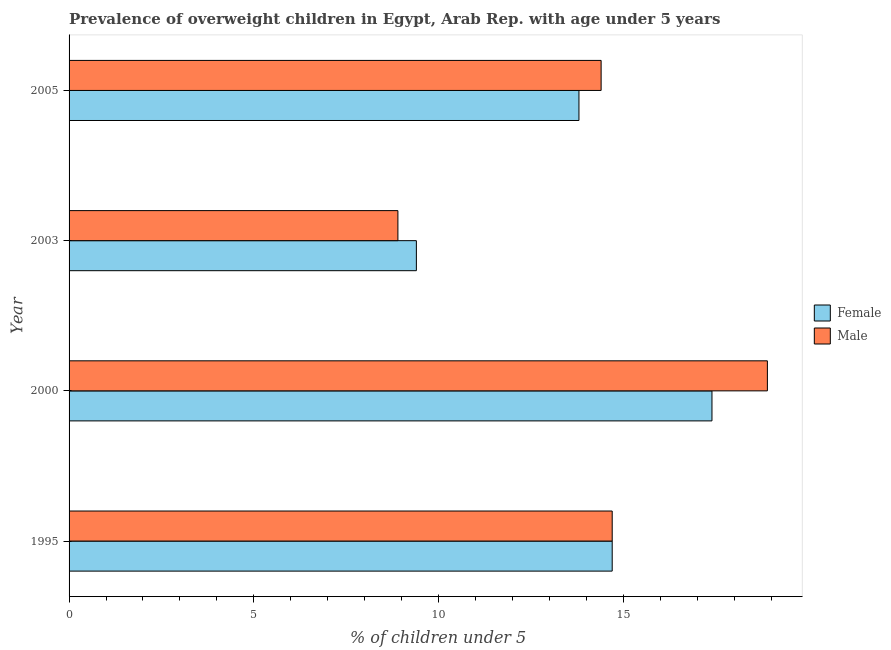How many different coloured bars are there?
Make the answer very short. 2. How many groups of bars are there?
Provide a succinct answer. 4. Are the number of bars on each tick of the Y-axis equal?
Provide a succinct answer. Yes. What is the label of the 4th group of bars from the top?
Provide a succinct answer. 1995. In how many cases, is the number of bars for a given year not equal to the number of legend labels?
Keep it short and to the point. 0. What is the percentage of obese female children in 2003?
Offer a very short reply. 9.4. Across all years, what is the maximum percentage of obese female children?
Give a very brief answer. 17.4. Across all years, what is the minimum percentage of obese male children?
Provide a short and direct response. 8.9. What is the total percentage of obese female children in the graph?
Give a very brief answer. 55.3. What is the difference between the percentage of obese female children in 1995 and that in 2000?
Provide a short and direct response. -2.7. What is the difference between the percentage of obese female children in 2000 and the percentage of obese male children in 2003?
Give a very brief answer. 8.5. What is the average percentage of obese male children per year?
Your response must be concise. 14.22. What is the ratio of the percentage of obese female children in 1995 to that in 2000?
Give a very brief answer. 0.84. Is the difference between the percentage of obese male children in 1995 and 2000 greater than the difference between the percentage of obese female children in 1995 and 2000?
Offer a terse response. No. What is the difference between the highest and the second highest percentage of obese female children?
Ensure brevity in your answer.  2.7. In how many years, is the percentage of obese male children greater than the average percentage of obese male children taken over all years?
Offer a terse response. 3. Is the sum of the percentage of obese female children in 2000 and 2003 greater than the maximum percentage of obese male children across all years?
Your response must be concise. Yes. What does the 1st bar from the top in 2003 represents?
Provide a succinct answer. Male. What does the 1st bar from the bottom in 2003 represents?
Give a very brief answer. Female. How many bars are there?
Your response must be concise. 8. How many years are there in the graph?
Give a very brief answer. 4. What is the difference between two consecutive major ticks on the X-axis?
Offer a very short reply. 5. Where does the legend appear in the graph?
Your answer should be compact. Center right. How are the legend labels stacked?
Your answer should be very brief. Vertical. What is the title of the graph?
Provide a succinct answer. Prevalence of overweight children in Egypt, Arab Rep. with age under 5 years. Does "Goods and services" appear as one of the legend labels in the graph?
Give a very brief answer. No. What is the label or title of the X-axis?
Your answer should be compact.  % of children under 5. What is the  % of children under 5 in Female in 1995?
Offer a very short reply. 14.7. What is the  % of children under 5 in Male in 1995?
Offer a terse response. 14.7. What is the  % of children under 5 of Female in 2000?
Give a very brief answer. 17.4. What is the  % of children under 5 of Male in 2000?
Ensure brevity in your answer.  18.9. What is the  % of children under 5 in Female in 2003?
Make the answer very short. 9.4. What is the  % of children under 5 of Male in 2003?
Keep it short and to the point. 8.9. What is the  % of children under 5 in Female in 2005?
Your answer should be compact. 13.8. What is the  % of children under 5 of Male in 2005?
Offer a very short reply. 14.4. Across all years, what is the maximum  % of children under 5 in Female?
Offer a terse response. 17.4. Across all years, what is the maximum  % of children under 5 in Male?
Make the answer very short. 18.9. Across all years, what is the minimum  % of children under 5 in Female?
Make the answer very short. 9.4. Across all years, what is the minimum  % of children under 5 in Male?
Provide a short and direct response. 8.9. What is the total  % of children under 5 of Female in the graph?
Your answer should be compact. 55.3. What is the total  % of children under 5 in Male in the graph?
Offer a very short reply. 56.9. What is the difference between the  % of children under 5 in Female in 1995 and that in 2000?
Provide a succinct answer. -2.7. What is the difference between the  % of children under 5 of Female in 1995 and that in 2003?
Give a very brief answer. 5.3. What is the difference between the  % of children under 5 of Male in 1995 and that in 2005?
Make the answer very short. 0.3. What is the difference between the  % of children under 5 in Female in 2000 and that in 2003?
Ensure brevity in your answer.  8. What is the difference between the  % of children under 5 of Male in 2000 and that in 2003?
Your answer should be very brief. 10. What is the difference between the  % of children under 5 in Female in 2000 and that in 2005?
Your answer should be compact. 3.6. What is the difference between the  % of children under 5 of Female in 2003 and that in 2005?
Provide a succinct answer. -4.4. What is the difference between the  % of children under 5 of Female in 1995 and the  % of children under 5 of Male in 2000?
Ensure brevity in your answer.  -4.2. What is the difference between the  % of children under 5 in Female in 1995 and the  % of children under 5 in Male in 2005?
Give a very brief answer. 0.3. What is the difference between the  % of children under 5 in Female in 2000 and the  % of children under 5 in Male in 2005?
Ensure brevity in your answer.  3. What is the average  % of children under 5 in Female per year?
Your answer should be compact. 13.82. What is the average  % of children under 5 of Male per year?
Make the answer very short. 14.22. In the year 1995, what is the difference between the  % of children under 5 in Female and  % of children under 5 in Male?
Your answer should be compact. 0. In the year 2000, what is the difference between the  % of children under 5 of Female and  % of children under 5 of Male?
Your answer should be compact. -1.5. In the year 2003, what is the difference between the  % of children under 5 of Female and  % of children under 5 of Male?
Offer a very short reply. 0.5. What is the ratio of the  % of children under 5 of Female in 1995 to that in 2000?
Provide a succinct answer. 0.84. What is the ratio of the  % of children under 5 of Female in 1995 to that in 2003?
Offer a very short reply. 1.56. What is the ratio of the  % of children under 5 in Male in 1995 to that in 2003?
Ensure brevity in your answer.  1.65. What is the ratio of the  % of children under 5 in Female in 1995 to that in 2005?
Offer a very short reply. 1.07. What is the ratio of the  % of children under 5 of Male in 1995 to that in 2005?
Your response must be concise. 1.02. What is the ratio of the  % of children under 5 in Female in 2000 to that in 2003?
Give a very brief answer. 1.85. What is the ratio of the  % of children under 5 in Male in 2000 to that in 2003?
Give a very brief answer. 2.12. What is the ratio of the  % of children under 5 of Female in 2000 to that in 2005?
Give a very brief answer. 1.26. What is the ratio of the  % of children under 5 of Male in 2000 to that in 2005?
Your response must be concise. 1.31. What is the ratio of the  % of children under 5 in Female in 2003 to that in 2005?
Make the answer very short. 0.68. What is the ratio of the  % of children under 5 in Male in 2003 to that in 2005?
Your answer should be compact. 0.62. What is the difference between the highest and the second highest  % of children under 5 in Female?
Your answer should be very brief. 2.7. What is the difference between the highest and the second highest  % of children under 5 in Male?
Your response must be concise. 4.2. What is the difference between the highest and the lowest  % of children under 5 in Female?
Ensure brevity in your answer.  8. 